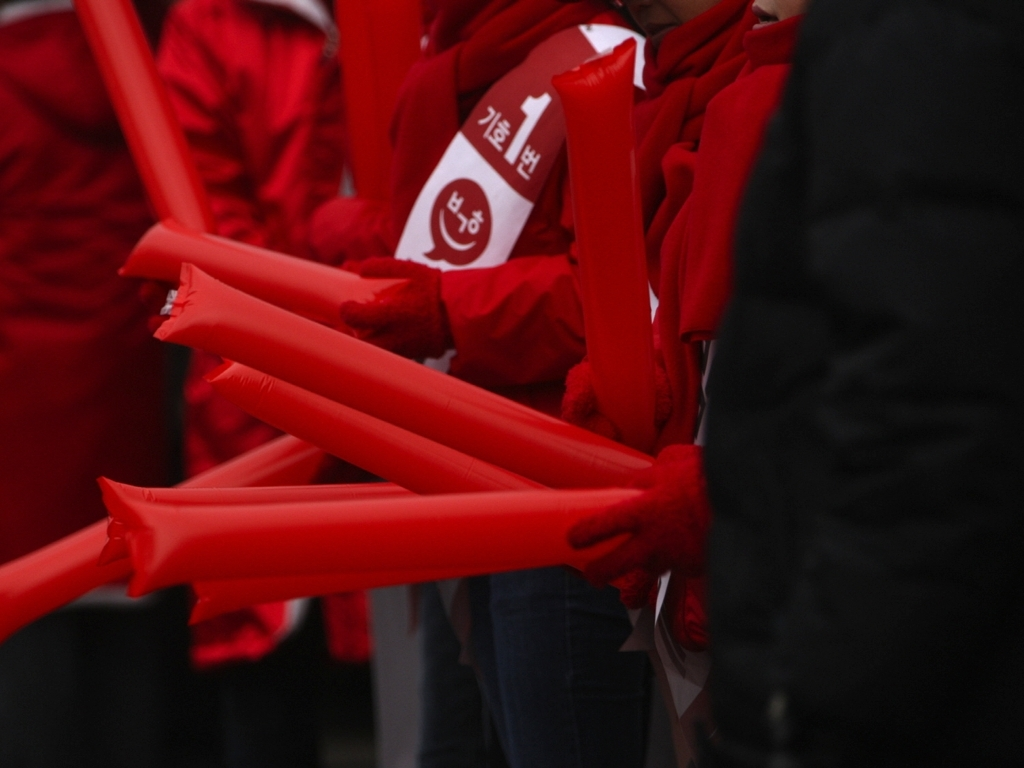What might the blurred background and focused foreground tell us about the photographer's intent? The photographer's choice to blur the background while keeping the red objects in the foreground in sharp focus suggests an intent to highlight the action or theme represented by these objects, isolating them from context to stress their importance. This technique directs the viewer's attention to the subject, emphasizing the emotion or message conveyed by this gathering. 